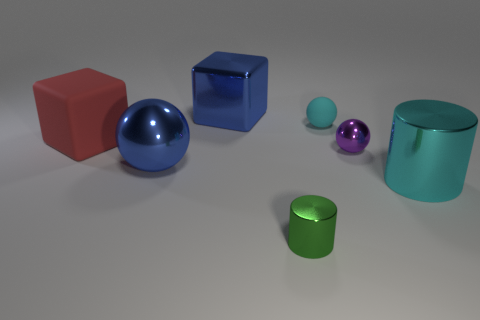Add 1 balls. How many objects exist? 8 Subtract all cylinders. How many objects are left? 5 Subtract all gray rubber cylinders. Subtract all rubber balls. How many objects are left? 6 Add 7 big blocks. How many big blocks are left? 9 Add 1 tiny red shiny things. How many tiny red shiny things exist? 1 Subtract 0 brown blocks. How many objects are left? 7 